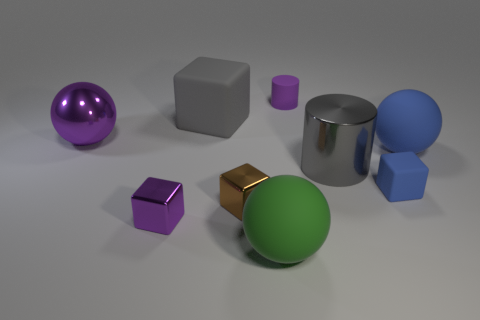Can you tell me what materials the objects in the image are made of based on their appearance? Certainly! The objects seem to be made of various materials based on their surfaces and reflections. The sphere on the left appears to be metallic due to its reflective surface and highlights. The cube in the center seems to have a matte finish, suggesting a plastic or rubber-like material. The large object behind it has a metallic sheen, indicative of a metal or chrome finish, while the cylinder on the right has a gloss that could be either a plastic or painted metal. 